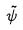<formula> <loc_0><loc_0><loc_500><loc_500>\tilde { \psi }</formula> 